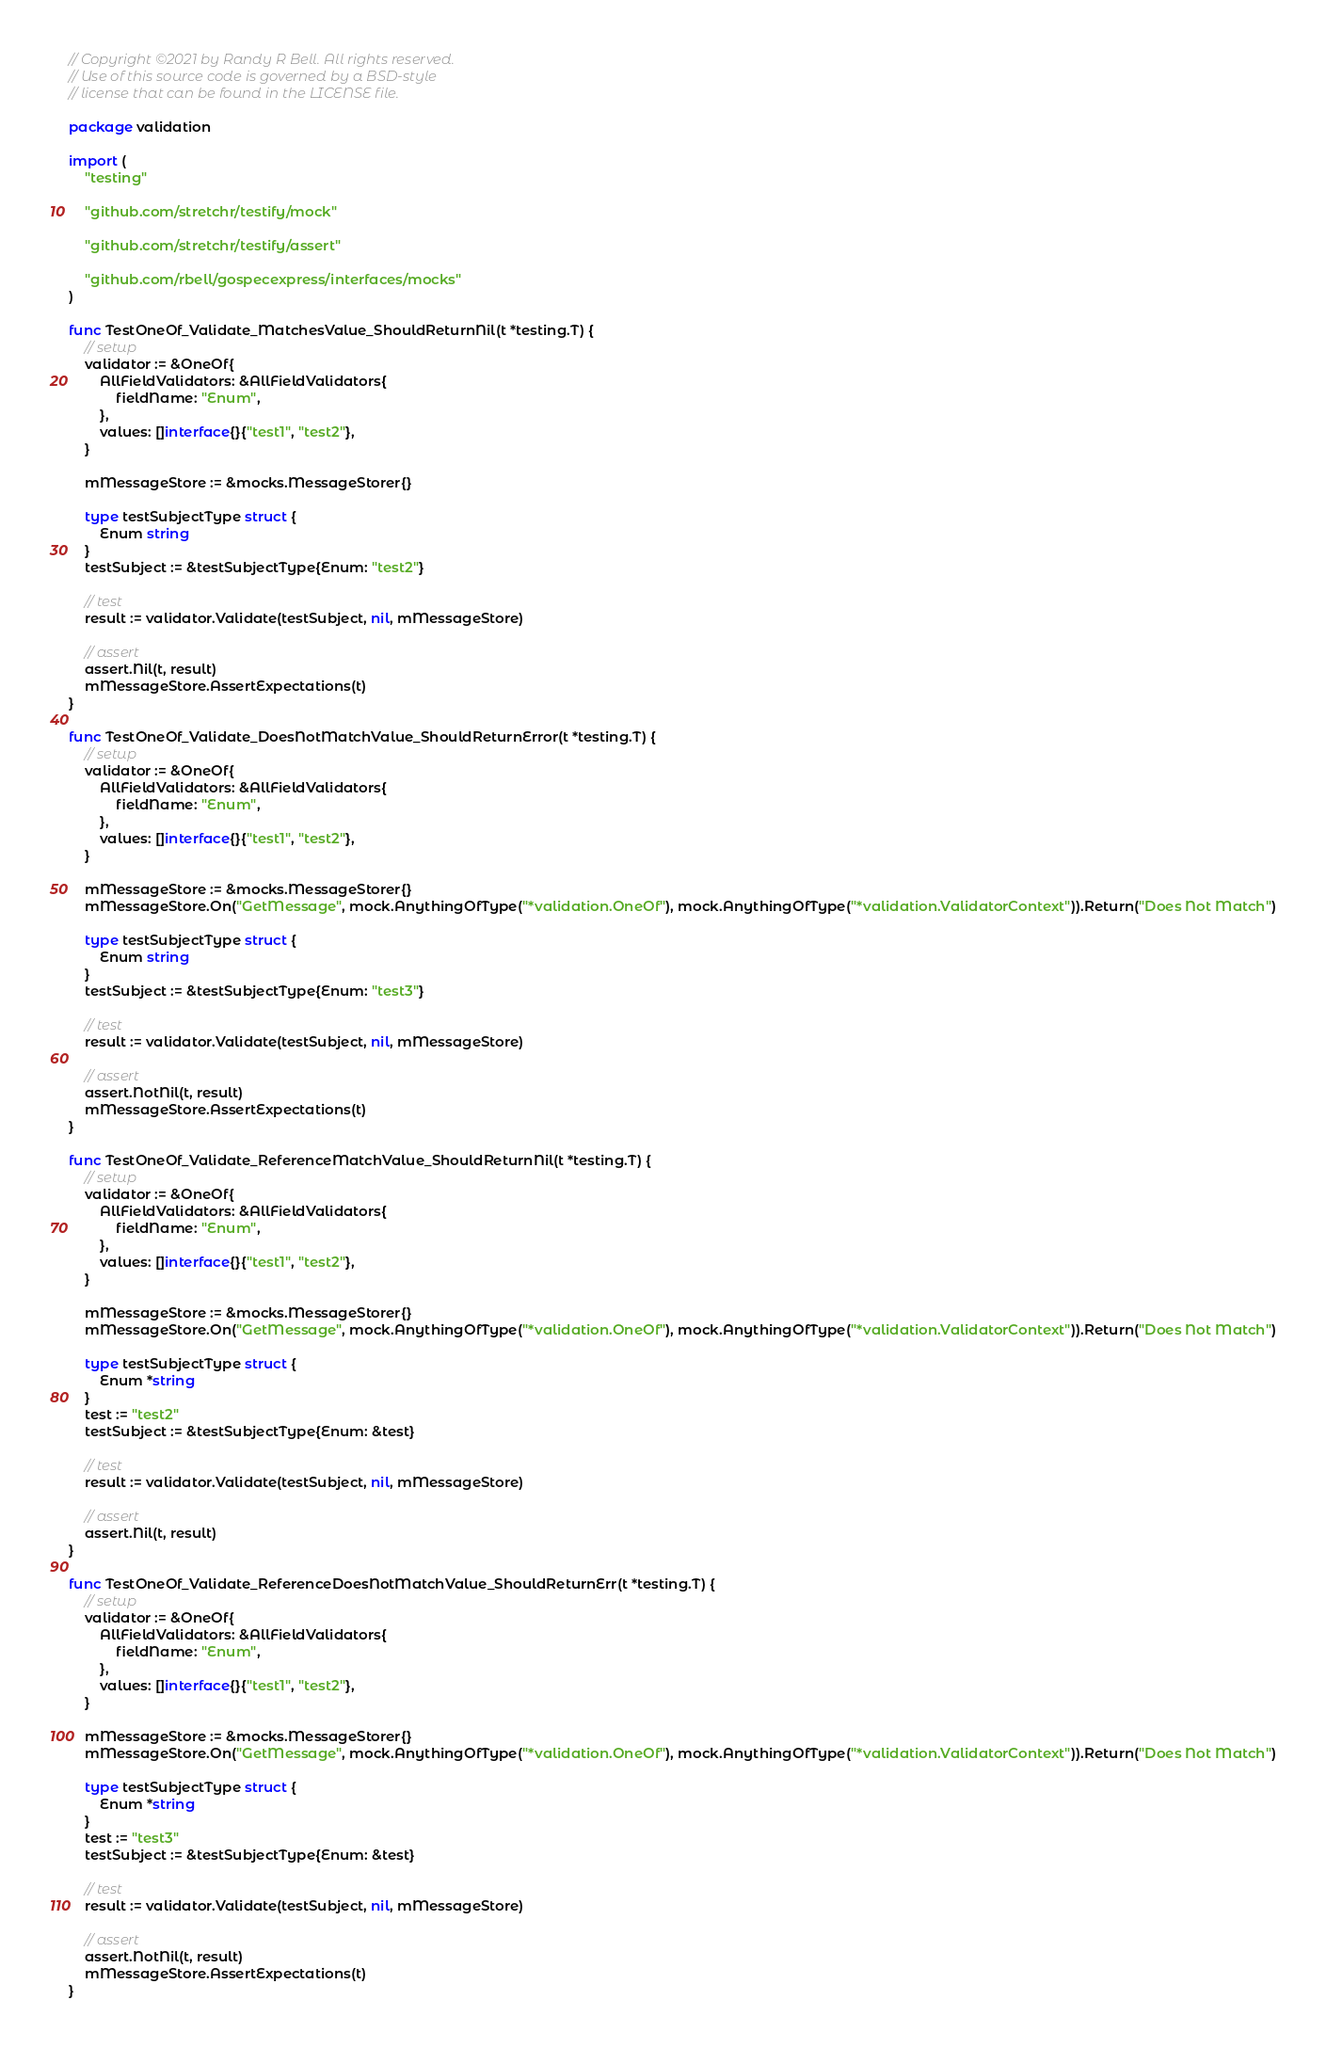<code> <loc_0><loc_0><loc_500><loc_500><_Go_>// Copyright ©2021 by Randy R Bell. All rights reserved.
// Use of this source code is governed by a BSD-style
// license that can be found in the LICENSE file.

package validation

import (
	"testing"

	"github.com/stretchr/testify/mock"

	"github.com/stretchr/testify/assert"

	"github.com/rbell/gospecexpress/interfaces/mocks"
)

func TestOneOf_Validate_MatchesValue_ShouldReturnNil(t *testing.T) {
	// setup
	validator := &OneOf{
		AllFieldValidators: &AllFieldValidators{
			fieldName: "Enum",
		},
		values: []interface{}{"test1", "test2"},
	}

	mMessageStore := &mocks.MessageStorer{}

	type testSubjectType struct {
		Enum string
	}
	testSubject := &testSubjectType{Enum: "test2"}

	// test
	result := validator.Validate(testSubject, nil, mMessageStore)

	// assert
	assert.Nil(t, result)
	mMessageStore.AssertExpectations(t)
}

func TestOneOf_Validate_DoesNotMatchValue_ShouldReturnError(t *testing.T) {
	// setup
	validator := &OneOf{
		AllFieldValidators: &AllFieldValidators{
			fieldName: "Enum",
		},
		values: []interface{}{"test1", "test2"},
	}

	mMessageStore := &mocks.MessageStorer{}
	mMessageStore.On("GetMessage", mock.AnythingOfType("*validation.OneOf"), mock.AnythingOfType("*validation.ValidatorContext")).Return("Does Not Match")

	type testSubjectType struct {
		Enum string
	}
	testSubject := &testSubjectType{Enum: "test3"}

	// test
	result := validator.Validate(testSubject, nil, mMessageStore)

	// assert
	assert.NotNil(t, result)
	mMessageStore.AssertExpectations(t)
}

func TestOneOf_Validate_ReferenceMatchValue_ShouldReturnNil(t *testing.T) {
	// setup
	validator := &OneOf{
		AllFieldValidators: &AllFieldValidators{
			fieldName: "Enum",
		},
		values: []interface{}{"test1", "test2"},
	}

	mMessageStore := &mocks.MessageStorer{}
	mMessageStore.On("GetMessage", mock.AnythingOfType("*validation.OneOf"), mock.AnythingOfType("*validation.ValidatorContext")).Return("Does Not Match")

	type testSubjectType struct {
		Enum *string
	}
	test := "test2"
	testSubject := &testSubjectType{Enum: &test}

	// test
	result := validator.Validate(testSubject, nil, mMessageStore)

	// assert
	assert.Nil(t, result)
}

func TestOneOf_Validate_ReferenceDoesNotMatchValue_ShouldReturnErr(t *testing.T) {
	// setup
	validator := &OneOf{
		AllFieldValidators: &AllFieldValidators{
			fieldName: "Enum",
		},
		values: []interface{}{"test1", "test2"},
	}

	mMessageStore := &mocks.MessageStorer{}
	mMessageStore.On("GetMessage", mock.AnythingOfType("*validation.OneOf"), mock.AnythingOfType("*validation.ValidatorContext")).Return("Does Not Match")

	type testSubjectType struct {
		Enum *string
	}
	test := "test3"
	testSubject := &testSubjectType{Enum: &test}

	// test
	result := validator.Validate(testSubject, nil, mMessageStore)

	// assert
	assert.NotNil(t, result)
	mMessageStore.AssertExpectations(t)
}
</code> 